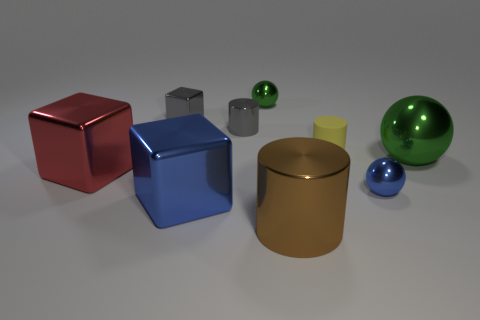Subtract all cylinders. How many objects are left? 6 Add 4 large cubes. How many large cubes exist? 6 Subtract 0 purple balls. How many objects are left? 9 Subtract all large brown objects. Subtract all large red shiny things. How many objects are left? 7 Add 4 red objects. How many red objects are left? 5 